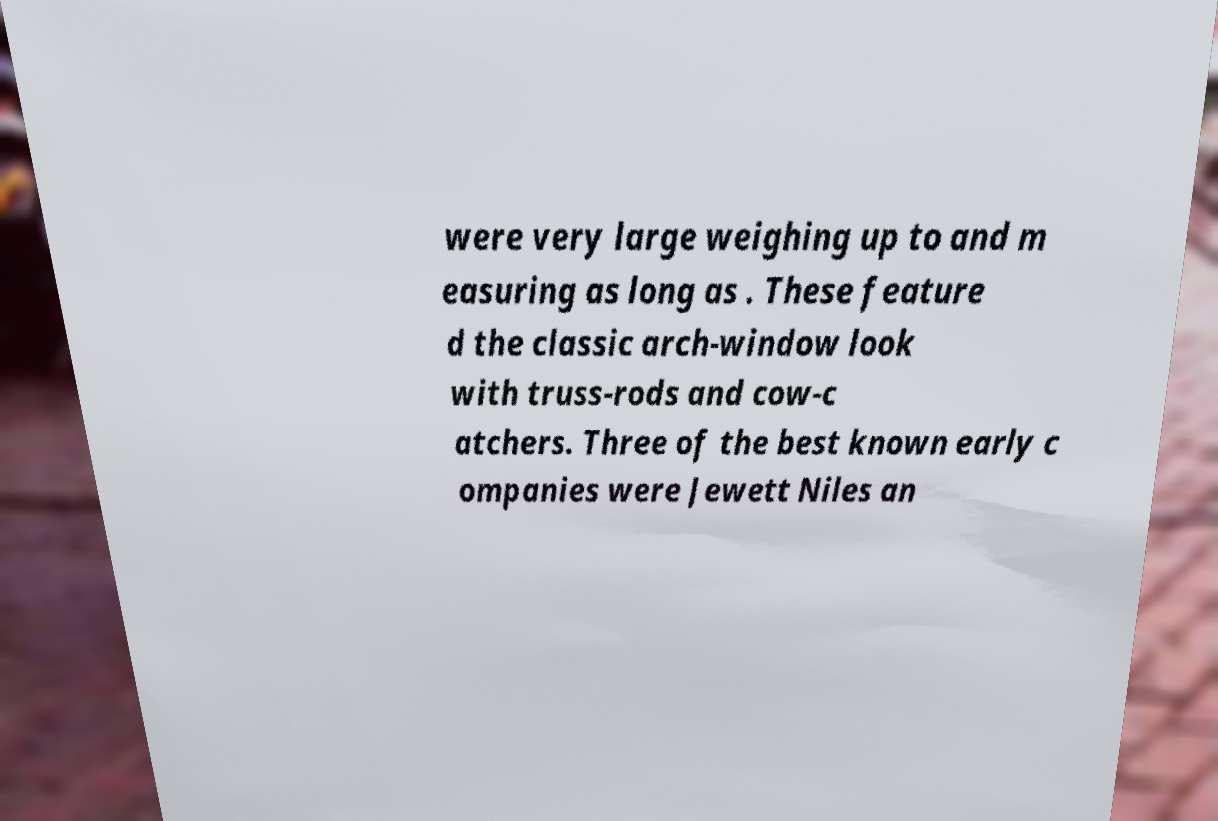Please identify and transcribe the text found in this image. were very large weighing up to and m easuring as long as . These feature d the classic arch-window look with truss-rods and cow-c atchers. Three of the best known early c ompanies were Jewett Niles an 